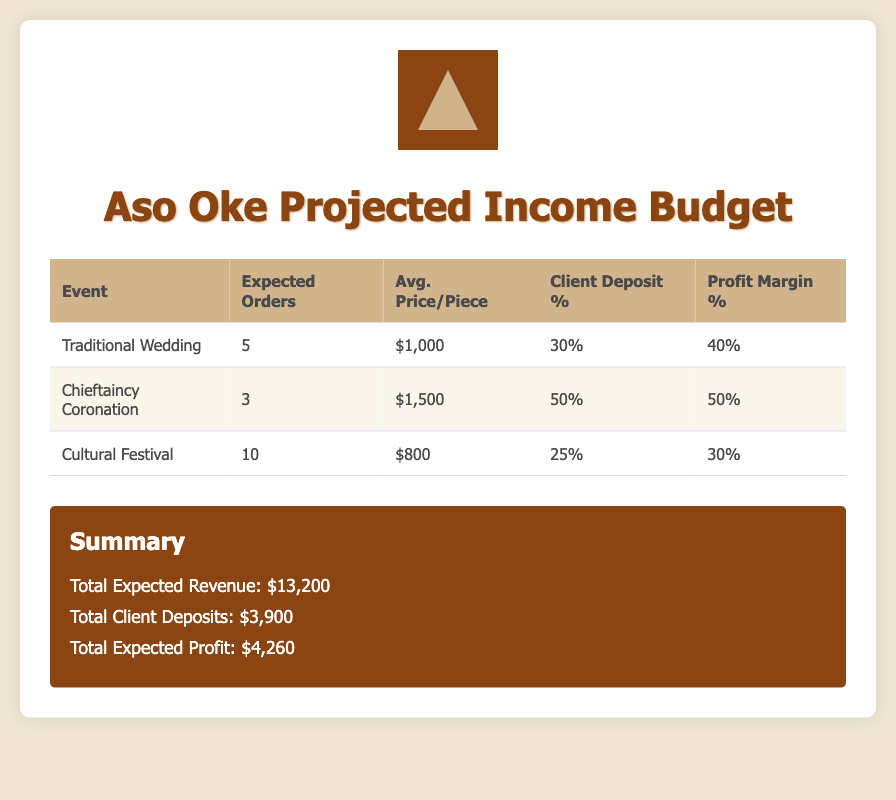What is the total expected revenue? The total expected revenue is displayed in the summary section of the document, which adds up the revenue from all events.
Answer: $13,200 What is the average price per piece for the Cultural Festival? The average price per piece for the Cultural Festival is listed in the corresponding row of the table.
Answer: $800 How many expected orders are there for the Chieftaincy Coronation? The expected orders for the Chieftaincy Coronation are shown in the second row of the table.
Answer: 3 What is the profit margin percentage for Traditional Wedding pieces? The profit margin percentage for Traditional Wedding pieces is specified in the table.
Answer: 40% What is the total client deposits amount? The total client deposits amount is provided in the summary section of the document, which includes all client deposits from the events.
Answer: $3,900 What is the client deposit percentage for the Cultural Festival? The client deposit percentage for the Cultural Festival is included in the table.
Answer: 25% Which event has the highest average price per piece? The event with the highest average price per piece can be determined by comparing the prices listed in the table.
Answer: Chieftaincy Coronation What is the expected profit from the Cultural Festival? The expected profit for each event can be calculated based on the average price per piece and profit margin; the specific value for the Cultural Festival is found in this reasoning.
Answer: Expected profit not specified directly in the document How many total events are listed in the budget? The number of events can be counted from the rows in the table, which detail each event.
Answer: 3 